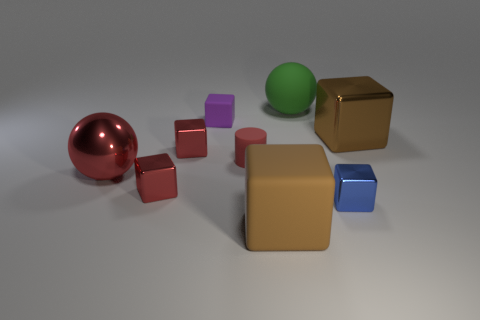Subtract all brown rubber cubes. How many cubes are left? 5 Subtract all red cubes. How many cubes are left? 4 Subtract all red balls. Subtract all purple cubes. How many balls are left? 1 Subtract all spheres. How many objects are left? 7 Add 6 brown shiny blocks. How many brown shiny blocks are left? 7 Add 5 small red metal blocks. How many small red metal blocks exist? 7 Subtract 0 cyan blocks. How many objects are left? 9 Subtract all tiny cyan shiny objects. Subtract all cylinders. How many objects are left? 8 